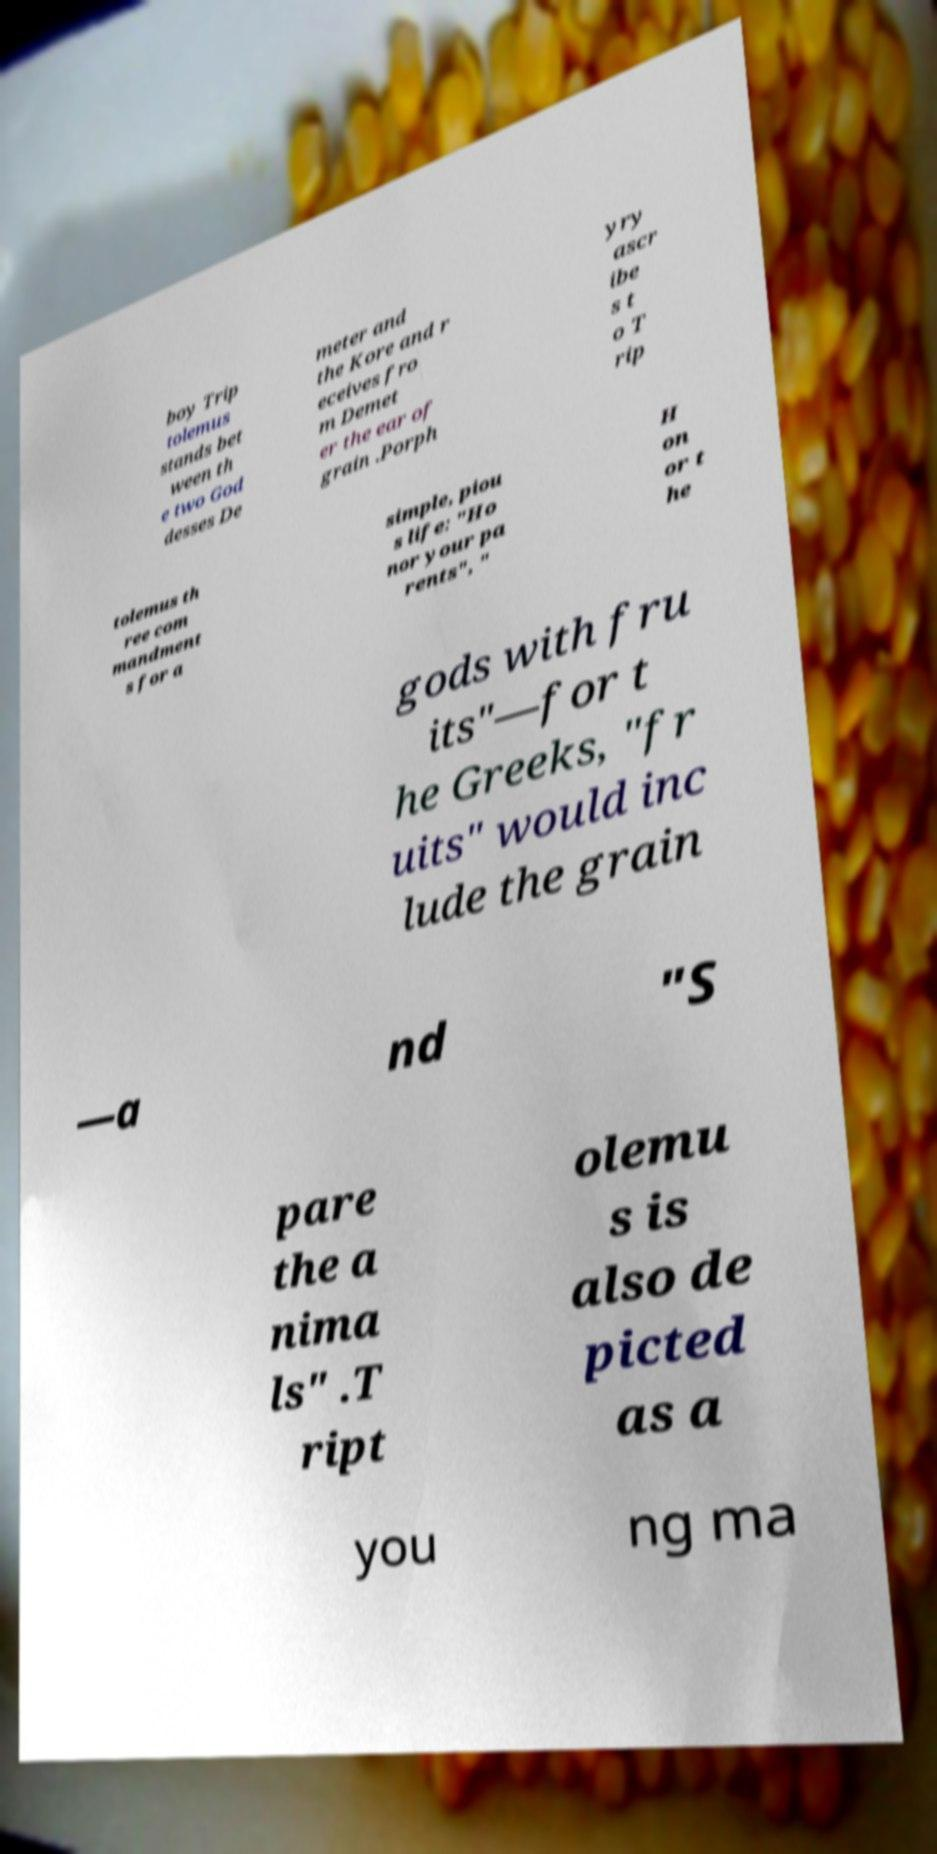Can you read and provide the text displayed in the image?This photo seems to have some interesting text. Can you extract and type it out for me? boy Trip tolemus stands bet ween th e two God desses De meter and the Kore and r eceives fro m Demet er the ear of grain .Porph yry ascr ibe s t o T rip tolemus th ree com mandment s for a simple, piou s life: "Ho nor your pa rents", " H on or t he gods with fru its"—for t he Greeks, "fr uits" would inc lude the grain —a nd "S pare the a nima ls" .T ript olemu s is also de picted as a you ng ma 